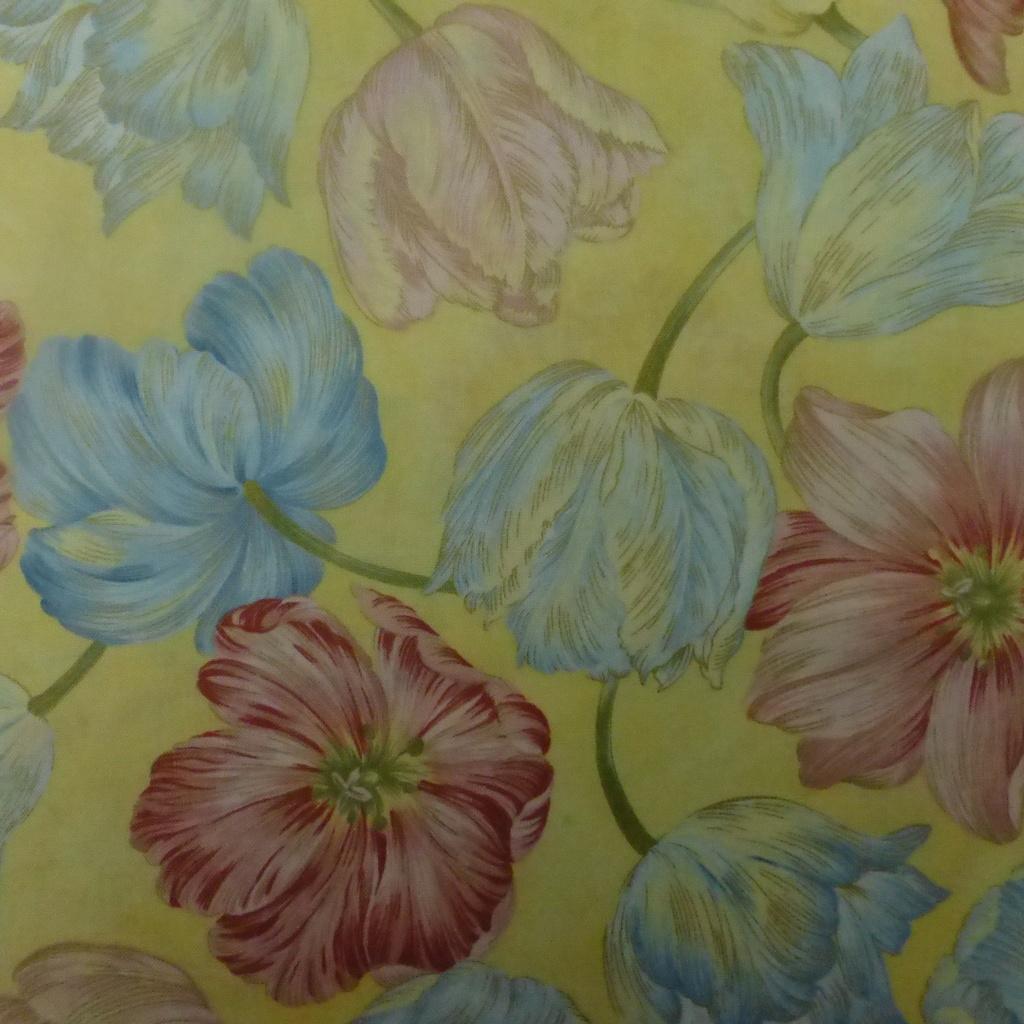Can you describe this image briefly? In this image I can see some flower paintings on a paper. The flowers are in blue and red colors and the paper is in yellow color. 